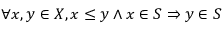Convert formula to latex. <formula><loc_0><loc_0><loc_500><loc_500>\forall x , y \in X , x \leq y \wedge x \in S \Rightarrow y \in S</formula> 